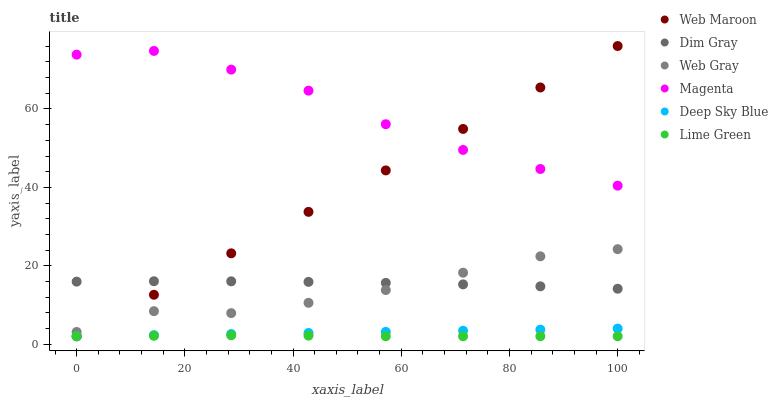Does Lime Green have the minimum area under the curve?
Answer yes or no. Yes. Does Magenta have the maximum area under the curve?
Answer yes or no. Yes. Does Web Maroon have the minimum area under the curve?
Answer yes or no. No. Does Web Maroon have the maximum area under the curve?
Answer yes or no. No. Is Deep Sky Blue the smoothest?
Answer yes or no. Yes. Is Magenta the roughest?
Answer yes or no. Yes. Is Web Maroon the smoothest?
Answer yes or no. No. Is Web Maroon the roughest?
Answer yes or no. No. Does Web Maroon have the lowest value?
Answer yes or no. Yes. Does Dim Gray have the lowest value?
Answer yes or no. No. Does Web Maroon have the highest value?
Answer yes or no. Yes. Does Dim Gray have the highest value?
Answer yes or no. No. Is Lime Green less than Web Gray?
Answer yes or no. Yes. Is Dim Gray greater than Lime Green?
Answer yes or no. Yes. Does Web Maroon intersect Dim Gray?
Answer yes or no. Yes. Is Web Maroon less than Dim Gray?
Answer yes or no. No. Is Web Maroon greater than Dim Gray?
Answer yes or no. No. Does Lime Green intersect Web Gray?
Answer yes or no. No. 